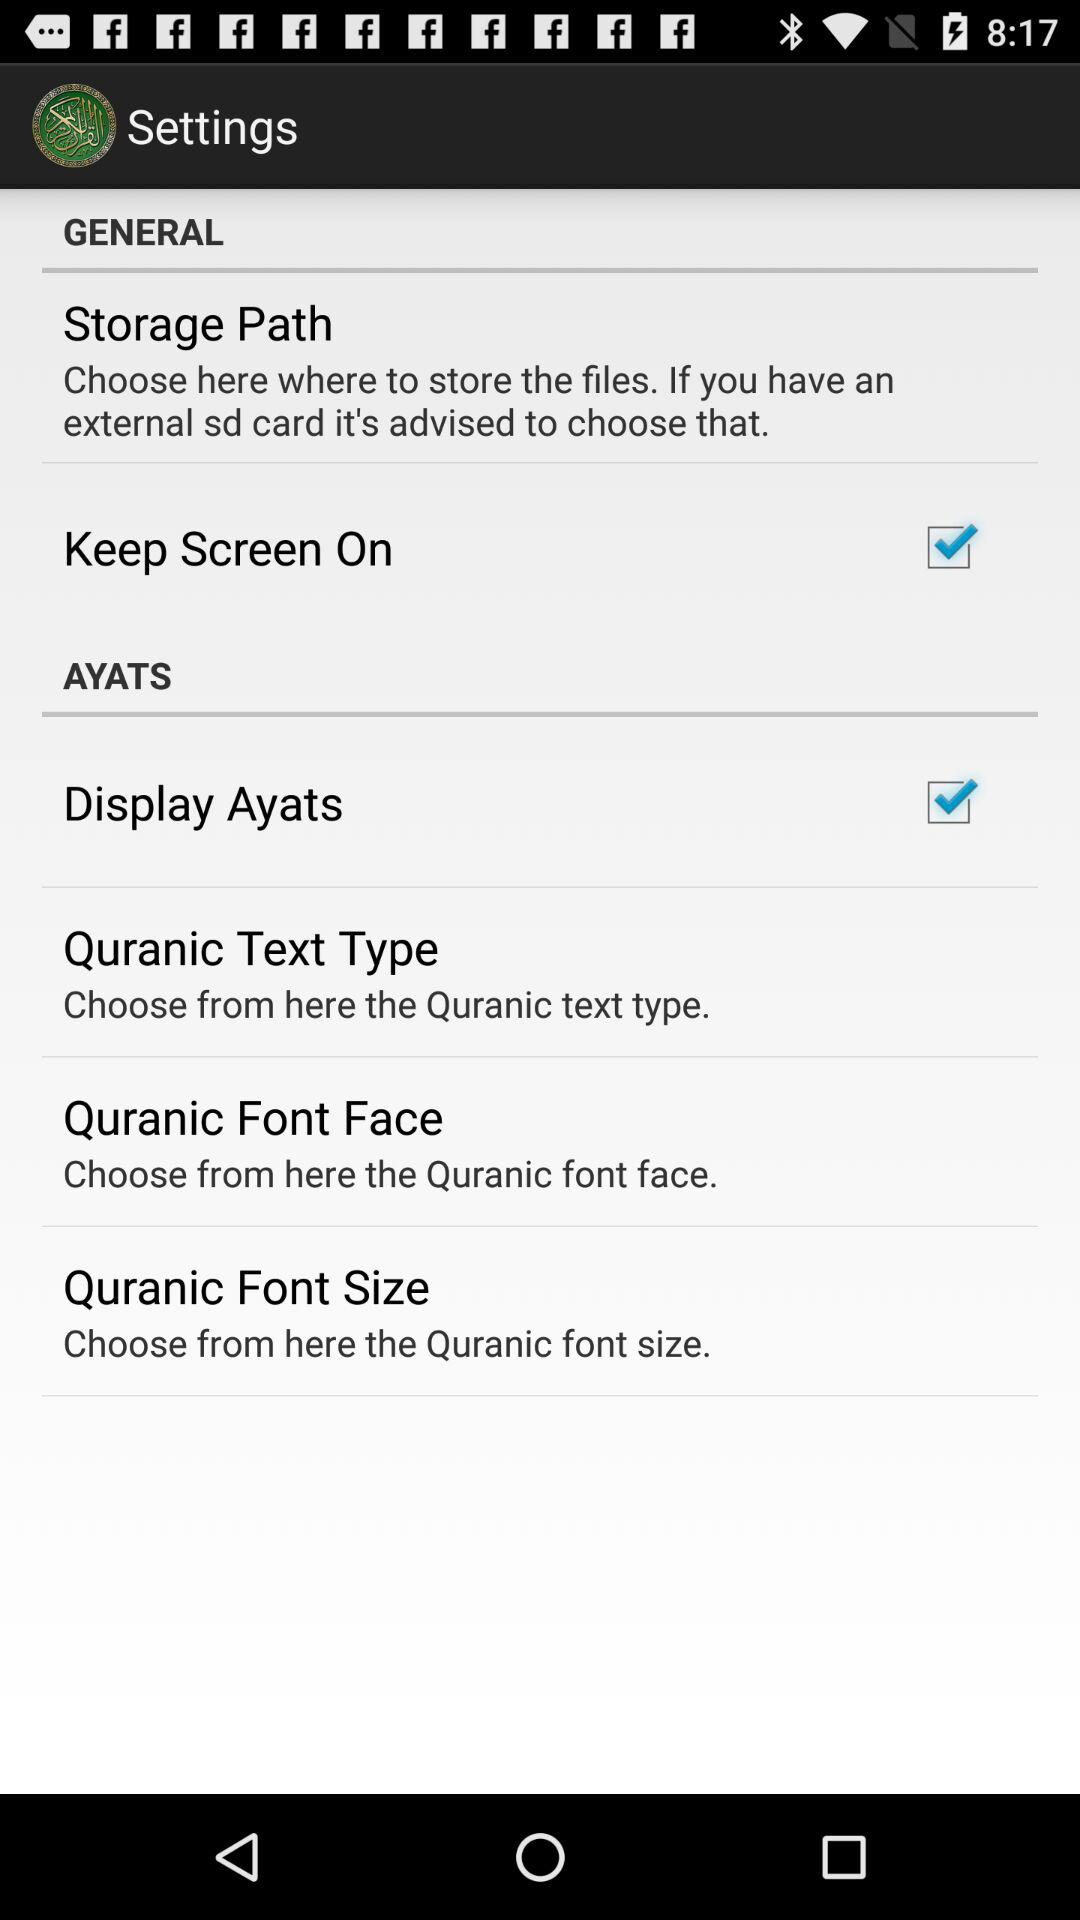How many items have a checkbox in the settings menu?
Answer the question using a single word or phrase. 2 